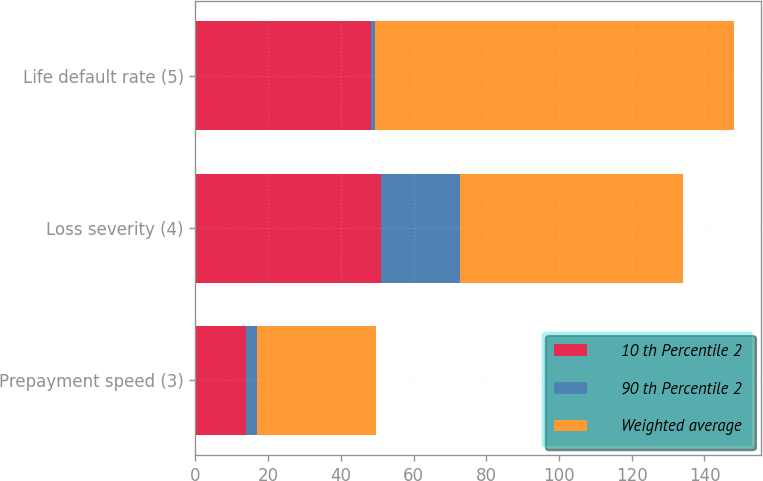Convert chart to OTSL. <chart><loc_0><loc_0><loc_500><loc_500><stacked_bar_chart><ecel><fcel>Prepayment speed (3)<fcel>Loss severity (4)<fcel>Life default rate (5)<nl><fcel>10 th Percentile 2<fcel>14<fcel>51<fcel>48.4<nl><fcel>90 th Percentile 2<fcel>3<fcel>21.8<fcel>1.1<nl><fcel>Weighted average<fcel>32.7<fcel>61.3<fcel>98.7<nl></chart> 